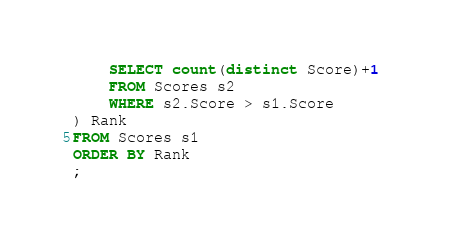<code> <loc_0><loc_0><loc_500><loc_500><_SQL_>    SELECT count(distinct Score)+1 
    FROM Scores s2
    WHERE s2.Score > s1.Score
) Rank 
FROM Scores s1 
ORDER BY Rank
;
</code> 